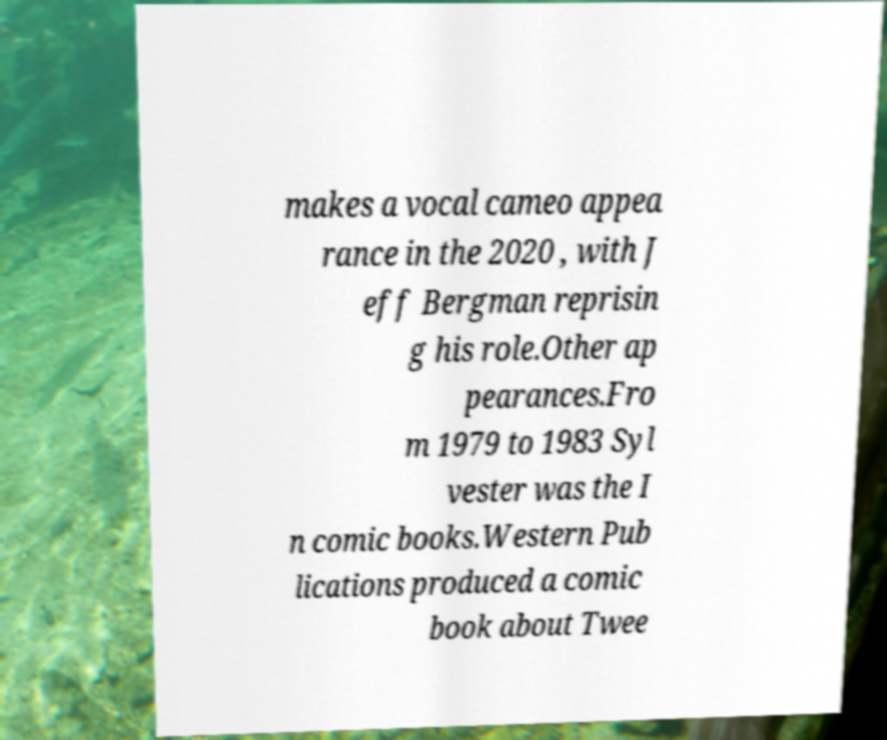For documentation purposes, I need the text within this image transcribed. Could you provide that? makes a vocal cameo appea rance in the 2020 , with J eff Bergman reprisin g his role.Other ap pearances.Fro m 1979 to 1983 Syl vester was the I n comic books.Western Pub lications produced a comic book about Twee 